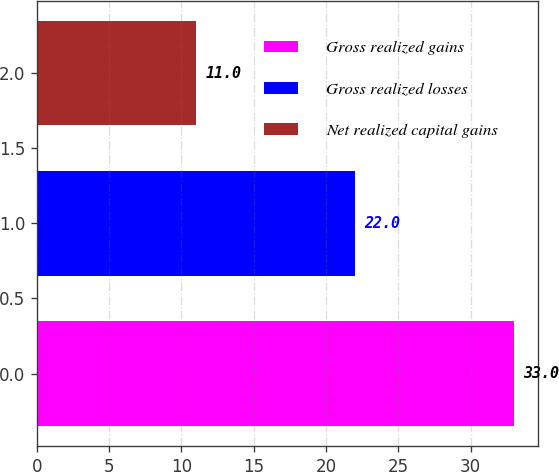Convert chart. <chart><loc_0><loc_0><loc_500><loc_500><bar_chart><fcel>Gross realized gains<fcel>Gross realized losses<fcel>Net realized capital gains<nl><fcel>33<fcel>22<fcel>11<nl></chart> 